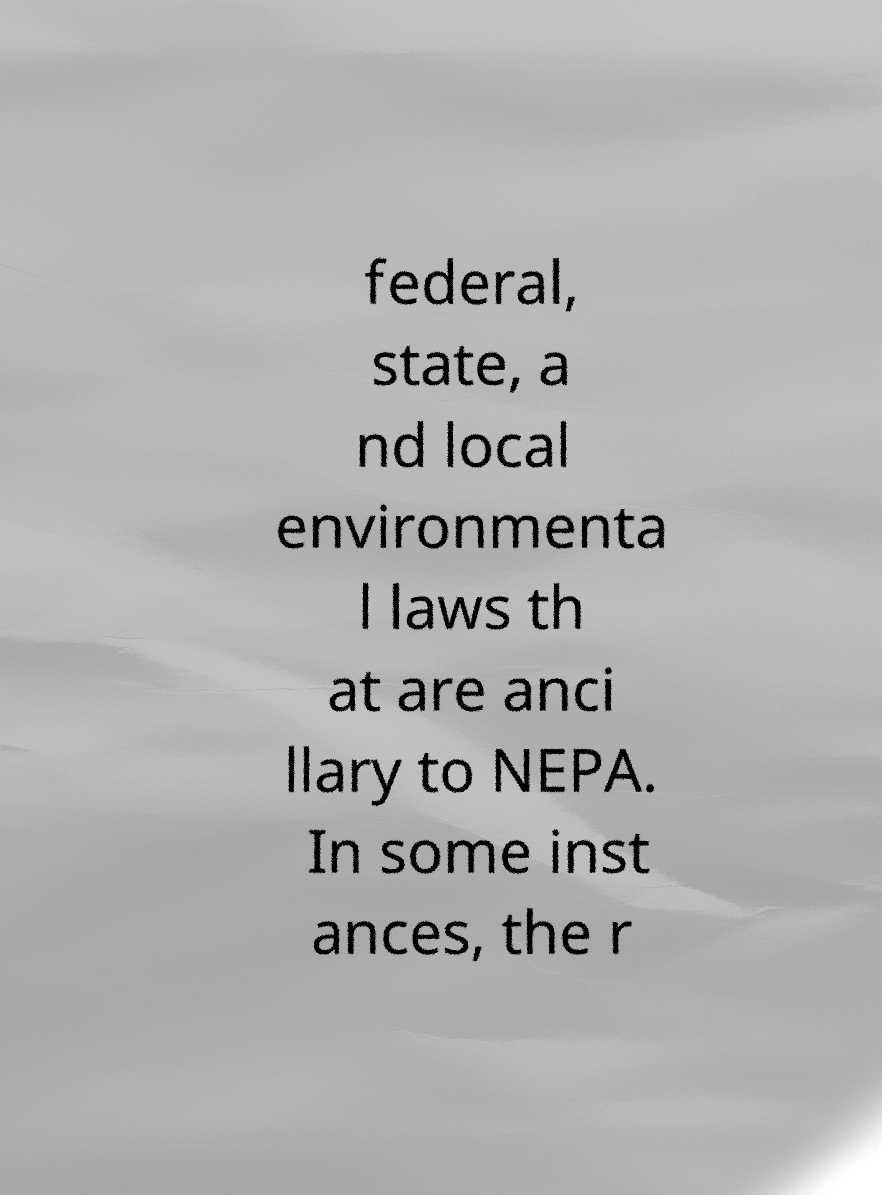For documentation purposes, I need the text within this image transcribed. Could you provide that? federal, state, a nd local environmenta l laws th at are anci llary to NEPA. In some inst ances, the r 